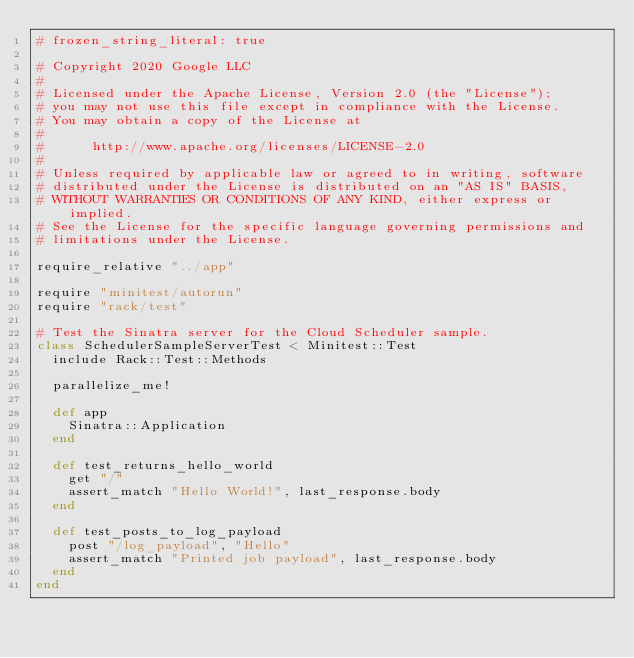<code> <loc_0><loc_0><loc_500><loc_500><_Ruby_># frozen_string_literal: true

# Copyright 2020 Google LLC
#
# Licensed under the Apache License, Version 2.0 (the "License");
# you may not use this file except in compliance with the License.
# You may obtain a copy of the License at
#
#      http://www.apache.org/licenses/LICENSE-2.0
#
# Unless required by applicable law or agreed to in writing, software
# distributed under the License is distributed on an "AS IS" BASIS,
# WITHOUT WARRANTIES OR CONDITIONS OF ANY KIND, either express or implied.
# See the License for the specific language governing permissions and
# limitations under the License.

require_relative "../app"

require "minitest/autorun"
require "rack/test"

# Test the Sinatra server for the Cloud Scheduler sample.
class SchedulerSampleServerTest < Minitest::Test
  include Rack::Test::Methods

  parallelize_me!

  def app
    Sinatra::Application
  end

  def test_returns_hello_world
    get "/"
    assert_match "Hello World!", last_response.body
  end

  def test_posts_to_log_payload
    post "/log_payload", "Hello"
    assert_match "Printed job payload", last_response.body
  end
end
</code> 